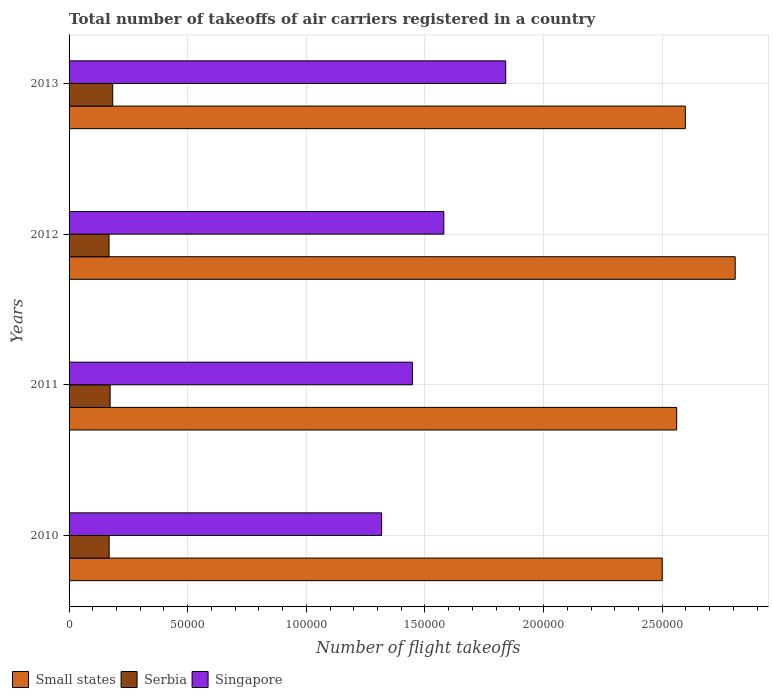How many different coloured bars are there?
Give a very brief answer. 3. Are the number of bars on each tick of the Y-axis equal?
Ensure brevity in your answer.  Yes. What is the label of the 2nd group of bars from the top?
Keep it short and to the point. 2012. In how many cases, is the number of bars for a given year not equal to the number of legend labels?
Your answer should be very brief. 0. What is the total number of flight takeoffs in Singapore in 2012?
Offer a very short reply. 1.58e+05. Across all years, what is the maximum total number of flight takeoffs in Serbia?
Provide a succinct answer. 1.84e+04. Across all years, what is the minimum total number of flight takeoffs in Serbia?
Offer a very short reply. 1.68e+04. In which year was the total number of flight takeoffs in Serbia maximum?
Provide a short and direct response. 2013. What is the total total number of flight takeoffs in Serbia in the graph?
Offer a terse response. 6.94e+04. What is the difference between the total number of flight takeoffs in Small states in 2011 and that in 2012?
Give a very brief answer. -2.47e+04. What is the difference between the total number of flight takeoffs in Small states in 2010 and the total number of flight takeoffs in Singapore in 2012?
Give a very brief answer. 9.21e+04. What is the average total number of flight takeoffs in Singapore per year?
Make the answer very short. 1.55e+05. In the year 2012, what is the difference between the total number of flight takeoffs in Serbia and total number of flight takeoffs in Singapore?
Provide a short and direct response. -1.41e+05. In how many years, is the total number of flight takeoffs in Serbia greater than 180000 ?
Keep it short and to the point. 0. What is the ratio of the total number of flight takeoffs in Small states in 2010 to that in 2012?
Give a very brief answer. 0.89. Is the difference between the total number of flight takeoffs in Serbia in 2010 and 2013 greater than the difference between the total number of flight takeoffs in Singapore in 2010 and 2013?
Keep it short and to the point. Yes. What is the difference between the highest and the second highest total number of flight takeoffs in Small states?
Provide a succinct answer. 2.10e+04. What is the difference between the highest and the lowest total number of flight takeoffs in Small states?
Provide a succinct answer. 3.07e+04. What does the 1st bar from the top in 2010 represents?
Provide a succinct answer. Singapore. What does the 1st bar from the bottom in 2010 represents?
Make the answer very short. Small states. How many bars are there?
Your response must be concise. 12. Are all the bars in the graph horizontal?
Give a very brief answer. Yes. How many years are there in the graph?
Give a very brief answer. 4. How many legend labels are there?
Offer a very short reply. 3. What is the title of the graph?
Your answer should be compact. Total number of takeoffs of air carriers registered in a country. What is the label or title of the X-axis?
Offer a very short reply. Number of flight takeoffs. What is the label or title of the Y-axis?
Offer a very short reply. Years. What is the Number of flight takeoffs of Small states in 2010?
Provide a short and direct response. 2.50e+05. What is the Number of flight takeoffs of Serbia in 2010?
Make the answer very short. 1.69e+04. What is the Number of flight takeoffs in Singapore in 2010?
Offer a terse response. 1.32e+05. What is the Number of flight takeoffs in Small states in 2011?
Provide a short and direct response. 2.56e+05. What is the Number of flight takeoffs in Serbia in 2011?
Your answer should be compact. 1.73e+04. What is the Number of flight takeoffs of Singapore in 2011?
Ensure brevity in your answer.  1.45e+05. What is the Number of flight takeoffs of Small states in 2012?
Provide a succinct answer. 2.81e+05. What is the Number of flight takeoffs in Serbia in 2012?
Your answer should be compact. 1.68e+04. What is the Number of flight takeoffs of Singapore in 2012?
Offer a terse response. 1.58e+05. What is the Number of flight takeoffs in Small states in 2013?
Ensure brevity in your answer.  2.60e+05. What is the Number of flight takeoffs of Serbia in 2013?
Keep it short and to the point. 1.84e+04. What is the Number of flight takeoffs in Singapore in 2013?
Ensure brevity in your answer.  1.84e+05. Across all years, what is the maximum Number of flight takeoffs of Small states?
Your response must be concise. 2.81e+05. Across all years, what is the maximum Number of flight takeoffs of Serbia?
Provide a succinct answer. 1.84e+04. Across all years, what is the maximum Number of flight takeoffs in Singapore?
Keep it short and to the point. 1.84e+05. Across all years, what is the minimum Number of flight takeoffs of Small states?
Your answer should be very brief. 2.50e+05. Across all years, what is the minimum Number of flight takeoffs in Serbia?
Your answer should be compact. 1.68e+04. Across all years, what is the minimum Number of flight takeoffs in Singapore?
Provide a short and direct response. 1.32e+05. What is the total Number of flight takeoffs of Small states in the graph?
Your answer should be compact. 1.05e+06. What is the total Number of flight takeoffs of Serbia in the graph?
Your response must be concise. 6.94e+04. What is the total Number of flight takeoffs of Singapore in the graph?
Your response must be concise. 6.18e+05. What is the difference between the Number of flight takeoffs of Small states in 2010 and that in 2011?
Ensure brevity in your answer.  -6074.31. What is the difference between the Number of flight takeoffs in Serbia in 2010 and that in 2011?
Your answer should be compact. -410. What is the difference between the Number of flight takeoffs of Singapore in 2010 and that in 2011?
Ensure brevity in your answer.  -1.30e+04. What is the difference between the Number of flight takeoffs of Small states in 2010 and that in 2012?
Your answer should be very brief. -3.07e+04. What is the difference between the Number of flight takeoffs of Singapore in 2010 and that in 2012?
Make the answer very short. -2.62e+04. What is the difference between the Number of flight takeoffs in Small states in 2010 and that in 2013?
Make the answer very short. -9728.7. What is the difference between the Number of flight takeoffs of Serbia in 2010 and that in 2013?
Provide a succinct answer. -1494.04. What is the difference between the Number of flight takeoffs in Singapore in 2010 and that in 2013?
Give a very brief answer. -5.23e+04. What is the difference between the Number of flight takeoffs in Small states in 2011 and that in 2012?
Your answer should be very brief. -2.47e+04. What is the difference between the Number of flight takeoffs of Serbia in 2011 and that in 2012?
Keep it short and to the point. 462. What is the difference between the Number of flight takeoffs in Singapore in 2011 and that in 2012?
Give a very brief answer. -1.32e+04. What is the difference between the Number of flight takeoffs of Small states in 2011 and that in 2013?
Ensure brevity in your answer.  -3654.38. What is the difference between the Number of flight takeoffs in Serbia in 2011 and that in 2013?
Provide a short and direct response. -1084.04. What is the difference between the Number of flight takeoffs in Singapore in 2011 and that in 2013?
Your answer should be very brief. -3.93e+04. What is the difference between the Number of flight takeoffs of Small states in 2012 and that in 2013?
Your answer should be compact. 2.10e+04. What is the difference between the Number of flight takeoffs of Serbia in 2012 and that in 2013?
Your answer should be compact. -1546.04. What is the difference between the Number of flight takeoffs of Singapore in 2012 and that in 2013?
Your answer should be compact. -2.61e+04. What is the difference between the Number of flight takeoffs in Small states in 2010 and the Number of flight takeoffs in Serbia in 2011?
Provide a short and direct response. 2.33e+05. What is the difference between the Number of flight takeoffs in Small states in 2010 and the Number of flight takeoffs in Singapore in 2011?
Make the answer very short. 1.05e+05. What is the difference between the Number of flight takeoffs of Serbia in 2010 and the Number of flight takeoffs of Singapore in 2011?
Your answer should be compact. -1.28e+05. What is the difference between the Number of flight takeoffs of Small states in 2010 and the Number of flight takeoffs of Serbia in 2012?
Your answer should be compact. 2.33e+05. What is the difference between the Number of flight takeoffs in Small states in 2010 and the Number of flight takeoffs in Singapore in 2012?
Your answer should be compact. 9.21e+04. What is the difference between the Number of flight takeoffs in Serbia in 2010 and the Number of flight takeoffs in Singapore in 2012?
Offer a terse response. -1.41e+05. What is the difference between the Number of flight takeoffs of Small states in 2010 and the Number of flight takeoffs of Serbia in 2013?
Make the answer very short. 2.32e+05. What is the difference between the Number of flight takeoffs in Small states in 2010 and the Number of flight takeoffs in Singapore in 2013?
Provide a succinct answer. 6.60e+04. What is the difference between the Number of flight takeoffs in Serbia in 2010 and the Number of flight takeoffs in Singapore in 2013?
Keep it short and to the point. -1.67e+05. What is the difference between the Number of flight takeoffs in Small states in 2011 and the Number of flight takeoffs in Serbia in 2012?
Ensure brevity in your answer.  2.39e+05. What is the difference between the Number of flight takeoffs of Small states in 2011 and the Number of flight takeoffs of Singapore in 2012?
Your answer should be compact. 9.81e+04. What is the difference between the Number of flight takeoffs in Serbia in 2011 and the Number of flight takeoffs in Singapore in 2012?
Offer a very short reply. -1.41e+05. What is the difference between the Number of flight takeoffs in Small states in 2011 and the Number of flight takeoffs in Serbia in 2013?
Give a very brief answer. 2.38e+05. What is the difference between the Number of flight takeoffs of Small states in 2011 and the Number of flight takeoffs of Singapore in 2013?
Make the answer very short. 7.20e+04. What is the difference between the Number of flight takeoffs of Serbia in 2011 and the Number of flight takeoffs of Singapore in 2013?
Offer a very short reply. -1.67e+05. What is the difference between the Number of flight takeoffs in Small states in 2012 and the Number of flight takeoffs in Serbia in 2013?
Your answer should be compact. 2.62e+05. What is the difference between the Number of flight takeoffs in Small states in 2012 and the Number of flight takeoffs in Singapore in 2013?
Ensure brevity in your answer.  9.67e+04. What is the difference between the Number of flight takeoffs in Serbia in 2012 and the Number of flight takeoffs in Singapore in 2013?
Provide a short and direct response. -1.67e+05. What is the average Number of flight takeoffs of Small states per year?
Offer a terse response. 2.62e+05. What is the average Number of flight takeoffs in Serbia per year?
Provide a short and direct response. 1.74e+04. What is the average Number of flight takeoffs in Singapore per year?
Give a very brief answer. 1.55e+05. In the year 2010, what is the difference between the Number of flight takeoffs in Small states and Number of flight takeoffs in Serbia?
Offer a very short reply. 2.33e+05. In the year 2010, what is the difference between the Number of flight takeoffs of Small states and Number of flight takeoffs of Singapore?
Your answer should be very brief. 1.18e+05. In the year 2010, what is the difference between the Number of flight takeoffs of Serbia and Number of flight takeoffs of Singapore?
Provide a succinct answer. -1.15e+05. In the year 2011, what is the difference between the Number of flight takeoffs of Small states and Number of flight takeoffs of Serbia?
Your answer should be very brief. 2.39e+05. In the year 2011, what is the difference between the Number of flight takeoffs in Small states and Number of flight takeoffs in Singapore?
Keep it short and to the point. 1.11e+05. In the year 2011, what is the difference between the Number of flight takeoffs of Serbia and Number of flight takeoffs of Singapore?
Keep it short and to the point. -1.27e+05. In the year 2012, what is the difference between the Number of flight takeoffs of Small states and Number of flight takeoffs of Serbia?
Your response must be concise. 2.64e+05. In the year 2012, what is the difference between the Number of flight takeoffs in Small states and Number of flight takeoffs in Singapore?
Offer a very short reply. 1.23e+05. In the year 2012, what is the difference between the Number of flight takeoffs of Serbia and Number of flight takeoffs of Singapore?
Your answer should be very brief. -1.41e+05. In the year 2013, what is the difference between the Number of flight takeoffs of Small states and Number of flight takeoffs of Serbia?
Keep it short and to the point. 2.41e+05. In the year 2013, what is the difference between the Number of flight takeoffs of Small states and Number of flight takeoffs of Singapore?
Make the answer very short. 7.57e+04. In the year 2013, what is the difference between the Number of flight takeoffs of Serbia and Number of flight takeoffs of Singapore?
Give a very brief answer. -1.66e+05. What is the ratio of the Number of flight takeoffs of Small states in 2010 to that in 2011?
Your answer should be compact. 0.98. What is the ratio of the Number of flight takeoffs in Serbia in 2010 to that in 2011?
Your answer should be very brief. 0.98. What is the ratio of the Number of flight takeoffs of Singapore in 2010 to that in 2011?
Your answer should be compact. 0.91. What is the ratio of the Number of flight takeoffs in Small states in 2010 to that in 2012?
Your answer should be very brief. 0.89. What is the ratio of the Number of flight takeoffs of Serbia in 2010 to that in 2012?
Provide a short and direct response. 1. What is the ratio of the Number of flight takeoffs in Singapore in 2010 to that in 2012?
Offer a very short reply. 0.83. What is the ratio of the Number of flight takeoffs in Small states in 2010 to that in 2013?
Your answer should be very brief. 0.96. What is the ratio of the Number of flight takeoffs in Serbia in 2010 to that in 2013?
Make the answer very short. 0.92. What is the ratio of the Number of flight takeoffs of Singapore in 2010 to that in 2013?
Your answer should be compact. 0.72. What is the ratio of the Number of flight takeoffs of Small states in 2011 to that in 2012?
Your answer should be very brief. 0.91. What is the ratio of the Number of flight takeoffs of Serbia in 2011 to that in 2012?
Provide a succinct answer. 1.03. What is the ratio of the Number of flight takeoffs in Singapore in 2011 to that in 2012?
Give a very brief answer. 0.92. What is the ratio of the Number of flight takeoffs in Small states in 2011 to that in 2013?
Your answer should be compact. 0.99. What is the ratio of the Number of flight takeoffs in Serbia in 2011 to that in 2013?
Give a very brief answer. 0.94. What is the ratio of the Number of flight takeoffs of Singapore in 2011 to that in 2013?
Offer a very short reply. 0.79. What is the ratio of the Number of flight takeoffs of Small states in 2012 to that in 2013?
Keep it short and to the point. 1.08. What is the ratio of the Number of flight takeoffs of Serbia in 2012 to that in 2013?
Offer a very short reply. 0.92. What is the ratio of the Number of flight takeoffs in Singapore in 2012 to that in 2013?
Make the answer very short. 0.86. What is the difference between the highest and the second highest Number of flight takeoffs in Small states?
Ensure brevity in your answer.  2.10e+04. What is the difference between the highest and the second highest Number of flight takeoffs in Serbia?
Give a very brief answer. 1084.04. What is the difference between the highest and the second highest Number of flight takeoffs of Singapore?
Keep it short and to the point. 2.61e+04. What is the difference between the highest and the lowest Number of flight takeoffs of Small states?
Provide a succinct answer. 3.07e+04. What is the difference between the highest and the lowest Number of flight takeoffs in Serbia?
Provide a short and direct response. 1546.04. What is the difference between the highest and the lowest Number of flight takeoffs of Singapore?
Keep it short and to the point. 5.23e+04. 